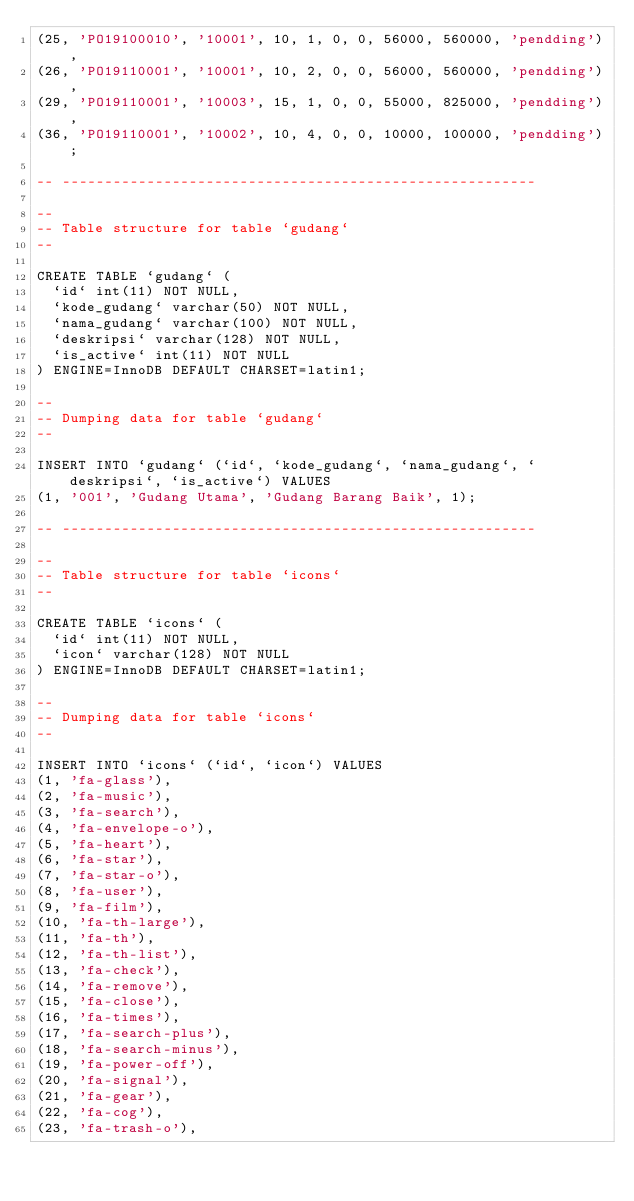Convert code to text. <code><loc_0><loc_0><loc_500><loc_500><_SQL_>(25, 'PO19100010', '10001', 10, 1, 0, 0, 56000, 560000, 'pendding'),
(26, 'PO19110001', '10001', 10, 2, 0, 0, 56000, 560000, 'pendding'),
(29, 'PO19110001', '10003', 15, 1, 0, 0, 55000, 825000, 'pendding'),
(36, 'PO19110001', '10002', 10, 4, 0, 0, 10000, 100000, 'pendding');

-- --------------------------------------------------------

--
-- Table structure for table `gudang`
--

CREATE TABLE `gudang` (
  `id` int(11) NOT NULL,
  `kode_gudang` varchar(50) NOT NULL,
  `nama_gudang` varchar(100) NOT NULL,
  `deskripsi` varchar(128) NOT NULL,
  `is_active` int(11) NOT NULL
) ENGINE=InnoDB DEFAULT CHARSET=latin1;

--
-- Dumping data for table `gudang`
--

INSERT INTO `gudang` (`id`, `kode_gudang`, `nama_gudang`, `deskripsi`, `is_active`) VALUES
(1, '001', 'Gudang Utama', 'Gudang Barang Baik', 1);

-- --------------------------------------------------------

--
-- Table structure for table `icons`
--

CREATE TABLE `icons` (
  `id` int(11) NOT NULL,
  `icon` varchar(128) NOT NULL
) ENGINE=InnoDB DEFAULT CHARSET=latin1;

--
-- Dumping data for table `icons`
--

INSERT INTO `icons` (`id`, `icon`) VALUES
(1, 'fa-glass'),
(2, 'fa-music'),
(3, 'fa-search'),
(4, 'fa-envelope-o'),
(5, 'fa-heart'),
(6, 'fa-star'),
(7, 'fa-star-o'),
(8, 'fa-user'),
(9, 'fa-film'),
(10, 'fa-th-large'),
(11, 'fa-th'),
(12, 'fa-th-list'),
(13, 'fa-check'),
(14, 'fa-remove'),
(15, 'fa-close'),
(16, 'fa-times'),
(17, 'fa-search-plus'),
(18, 'fa-search-minus'),
(19, 'fa-power-off'),
(20, 'fa-signal'),
(21, 'fa-gear'),
(22, 'fa-cog'),
(23, 'fa-trash-o'),</code> 